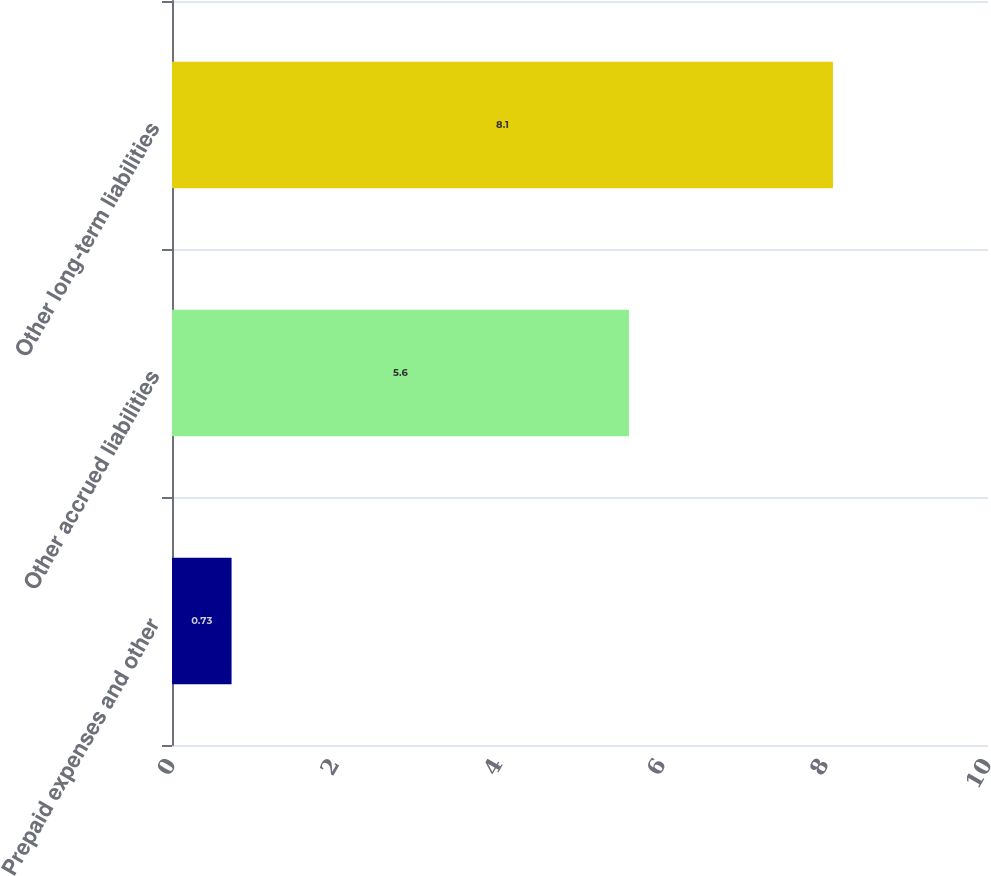Convert chart to OTSL. <chart><loc_0><loc_0><loc_500><loc_500><bar_chart><fcel>Prepaid expenses and other<fcel>Other accrued liabilities<fcel>Other long-term liabilities<nl><fcel>0.73<fcel>5.6<fcel>8.1<nl></chart> 